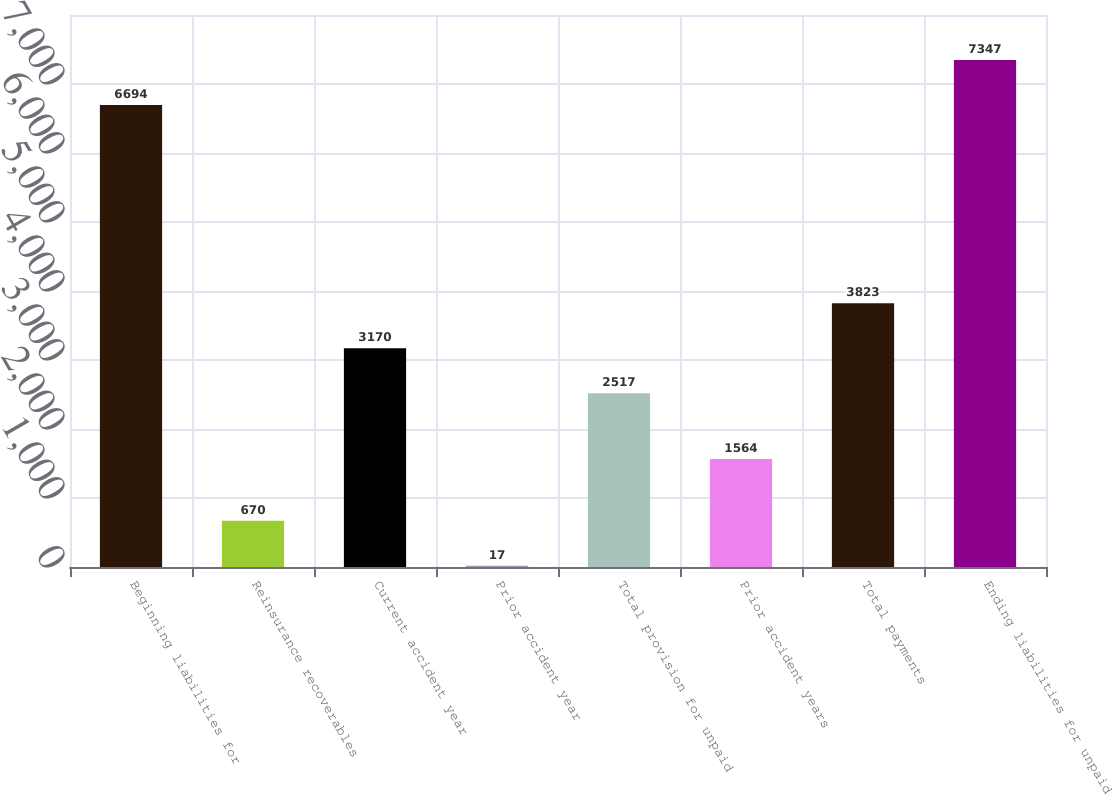Convert chart to OTSL. <chart><loc_0><loc_0><loc_500><loc_500><bar_chart><fcel>Beginning liabilities for<fcel>Reinsurance recoverables<fcel>Current accident year<fcel>Prior accident year<fcel>Total provision for unpaid<fcel>Prior accident years<fcel>Total payments<fcel>Ending liabilities for unpaid<nl><fcel>6694<fcel>670<fcel>3170<fcel>17<fcel>2517<fcel>1564<fcel>3823<fcel>7347<nl></chart> 